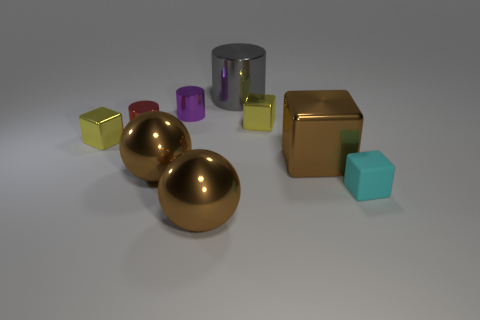Subtract all cyan matte cubes. How many cubes are left? 3 Subtract all brown cubes. How many cubes are left? 3 Subtract all balls. How many objects are left? 7 Subtract 3 cubes. How many cubes are left? 1 Add 1 big brown spheres. How many big brown spheres are left? 3 Add 6 small purple objects. How many small purple objects exist? 7 Subtract 0 red blocks. How many objects are left? 9 Subtract all purple cubes. Subtract all yellow balls. How many cubes are left? 4 Subtract all brown balls. How many gray cylinders are left? 1 Subtract all big gray metal cylinders. Subtract all large cyan matte balls. How many objects are left? 8 